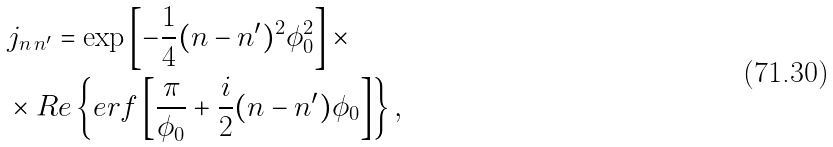Convert formula to latex. <formula><loc_0><loc_0><loc_500><loc_500>& j _ { n \, n ^ { \prime } } = \exp \left [ - \frac { 1 } { 4 } ( n - n ^ { \prime } ) ^ { 2 } \phi _ { 0 } ^ { 2 } \right ] \times \\ & \times R e \left \{ e r f \left [ \frac { \pi } { \phi _ { 0 } } + \frac { i } { 2 } ( n - n ^ { \prime } ) \phi _ { 0 } \right ] \right \} ,</formula> 